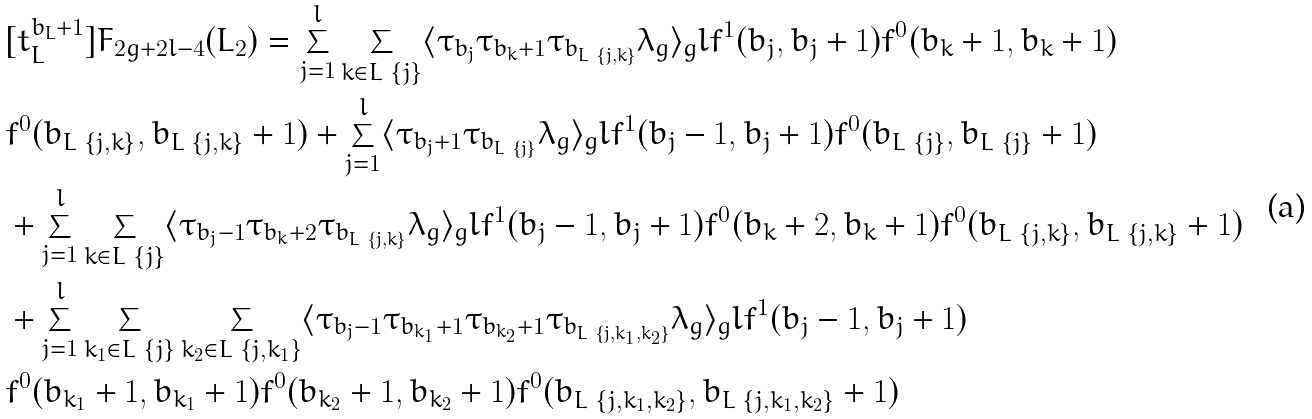Convert formula to latex. <formula><loc_0><loc_0><loc_500><loc_500>& [ t _ { L } ^ { b _ { L } + 1 } ] F _ { 2 g + 2 l - 4 } ( L _ { 2 } ) = \sum _ { j = 1 } ^ { l } \sum _ { k \in L \ \{ j \} } \langle \tau _ { b _ { j } } \tau _ { b _ { k } + 1 } \tau _ { b _ { L \ \{ j , k \} } } \lambda _ { g } \rangle _ { g } l f ^ { 1 } ( b _ { j } , b _ { j } + 1 ) f ^ { 0 } ( b _ { k } + 1 , b _ { k } + 1 ) \\ & f ^ { 0 } ( b _ { L \ \{ j , k \} } , b _ { L \ \{ j , k \} } + 1 ) + \sum _ { j = 1 } ^ { l } \langle \tau _ { b _ { j } + 1 } \tau _ { b _ { L \ \{ j \} } } \lambda _ { g } \rangle _ { g } l f ^ { 1 } ( b _ { j } - 1 , b _ { j } + 1 ) f ^ { 0 } ( b _ { L \ \{ j \} } , b _ { L \ \{ j \} } + 1 ) \\ & + \sum _ { j = 1 } ^ { l } \sum _ { k \in L \ \{ j \} } \langle \tau _ { b _ { j } - 1 } \tau _ { b _ { k } + 2 } \tau _ { b _ { L \ \{ j , k \} } } \lambda _ { g } \rangle _ { g } l f ^ { 1 } ( b _ { j } - 1 , b _ { j } + 1 ) f ^ { 0 } ( b _ { k } + 2 , b _ { k } + 1 ) f ^ { 0 } ( b _ { L \ \{ j , k \} } , b _ { L \ \{ j , k \} } + 1 ) \\ & + \sum _ { j = 1 } ^ { l } \sum _ { k _ { 1 } \in L \ \{ j \} } \sum _ { k _ { 2 } \in L \ \{ j , k _ { 1 } \} } \langle \tau _ { b _ { j } - 1 } \tau _ { b _ { k _ { 1 } } + 1 } \tau _ { b _ { k _ { 2 } } + 1 } \tau _ { b _ { L \ \{ j , k _ { 1 } , k _ { 2 } \} } } \lambda _ { g } \rangle _ { g } l f ^ { 1 } ( b _ { j } - 1 , b _ { j } + 1 ) \\ & f ^ { 0 } ( b _ { k _ { 1 } } + 1 , b _ { k _ { 1 } } + 1 ) f ^ { 0 } ( b _ { k _ { 2 } } + 1 , b _ { k _ { 2 } } + 1 ) f ^ { 0 } ( b _ { L \ \{ j , k _ { 1 } , k _ { 2 } \} } , b _ { L \ \{ j , k _ { 1 } , k _ { 2 } \} } + 1 )</formula> 